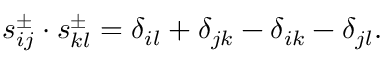Convert formula to latex. <formula><loc_0><loc_0><loc_500><loc_500>s _ { i j } ^ { \pm } \cdot s _ { k l } ^ { \pm } = \delta _ { i l } + \delta _ { j k } - \delta _ { i k } - \delta _ { j l } .</formula> 